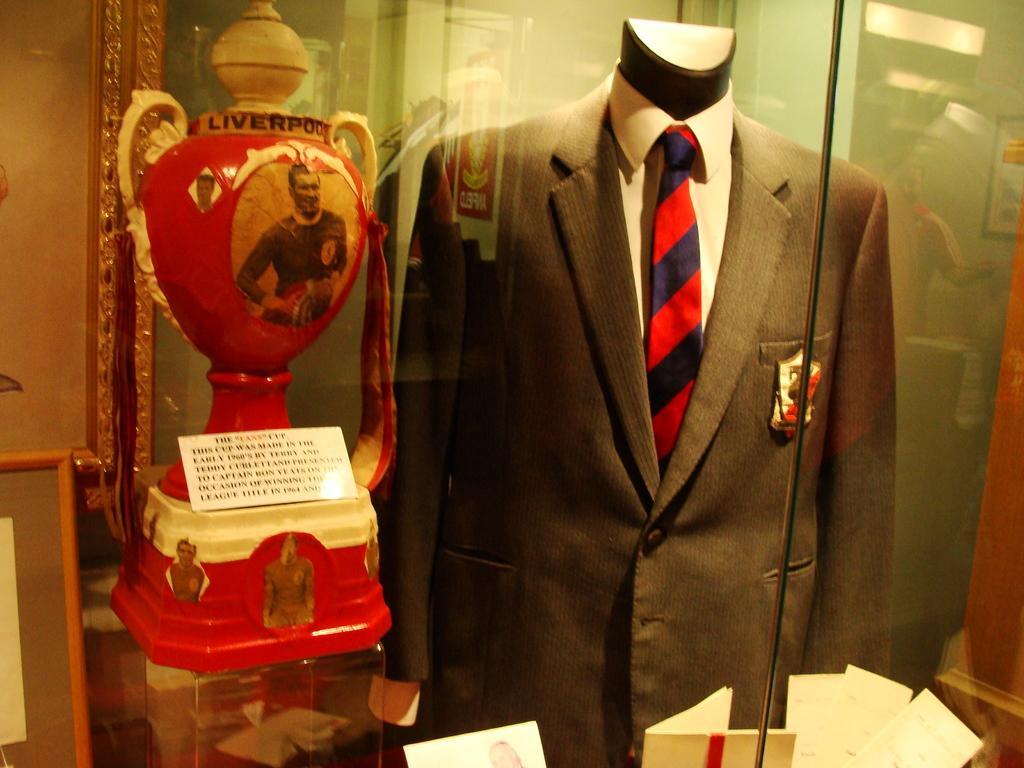Could you give a brief overview of what you see in this image? In this image we can see a coat, tie, shirt and a badge on a mannequin. On the left side we can see a trophy with some pictures of a person on it. On the bottom of the image we can see some papers. 